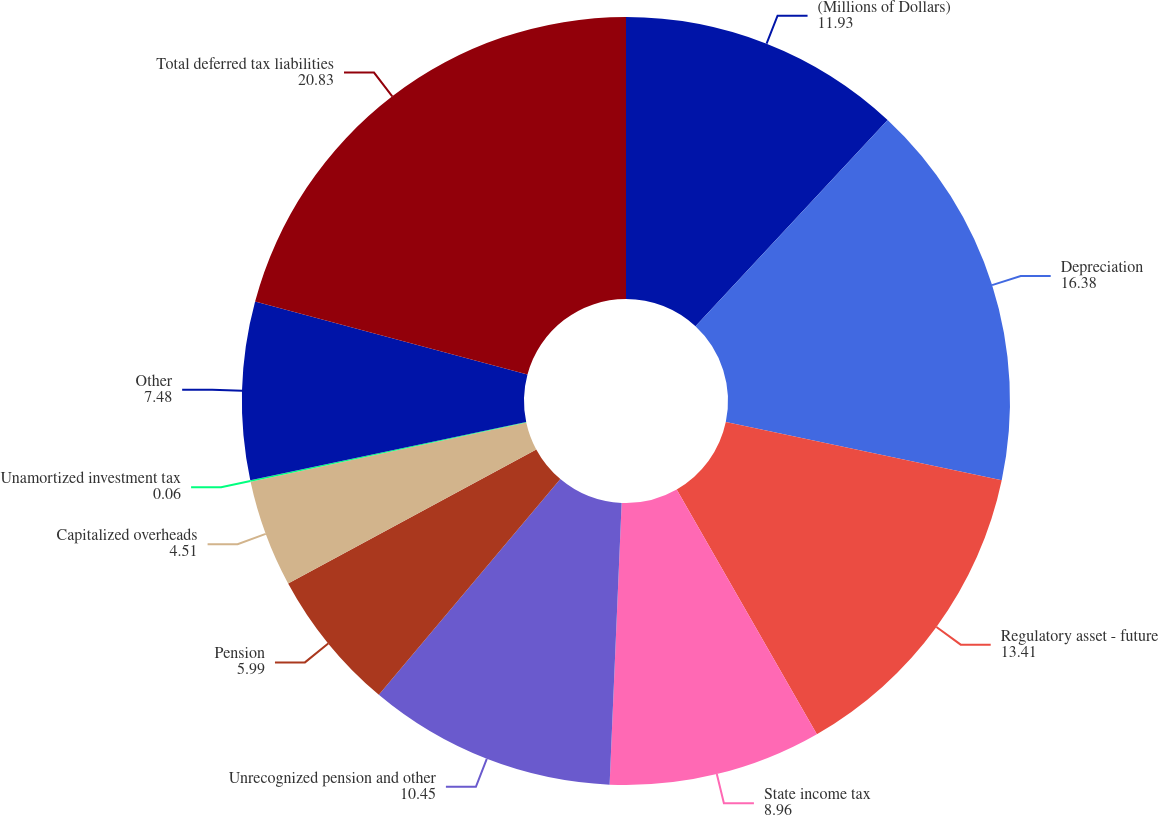Convert chart. <chart><loc_0><loc_0><loc_500><loc_500><pie_chart><fcel>(Millions of Dollars)<fcel>Depreciation<fcel>Regulatory asset - future<fcel>State income tax<fcel>Unrecognized pension and other<fcel>Pension<fcel>Capitalized overheads<fcel>Unamortized investment tax<fcel>Other<fcel>Total deferred tax liabilities<nl><fcel>11.93%<fcel>16.38%<fcel>13.41%<fcel>8.96%<fcel>10.45%<fcel>5.99%<fcel>4.51%<fcel>0.06%<fcel>7.48%<fcel>20.83%<nl></chart> 